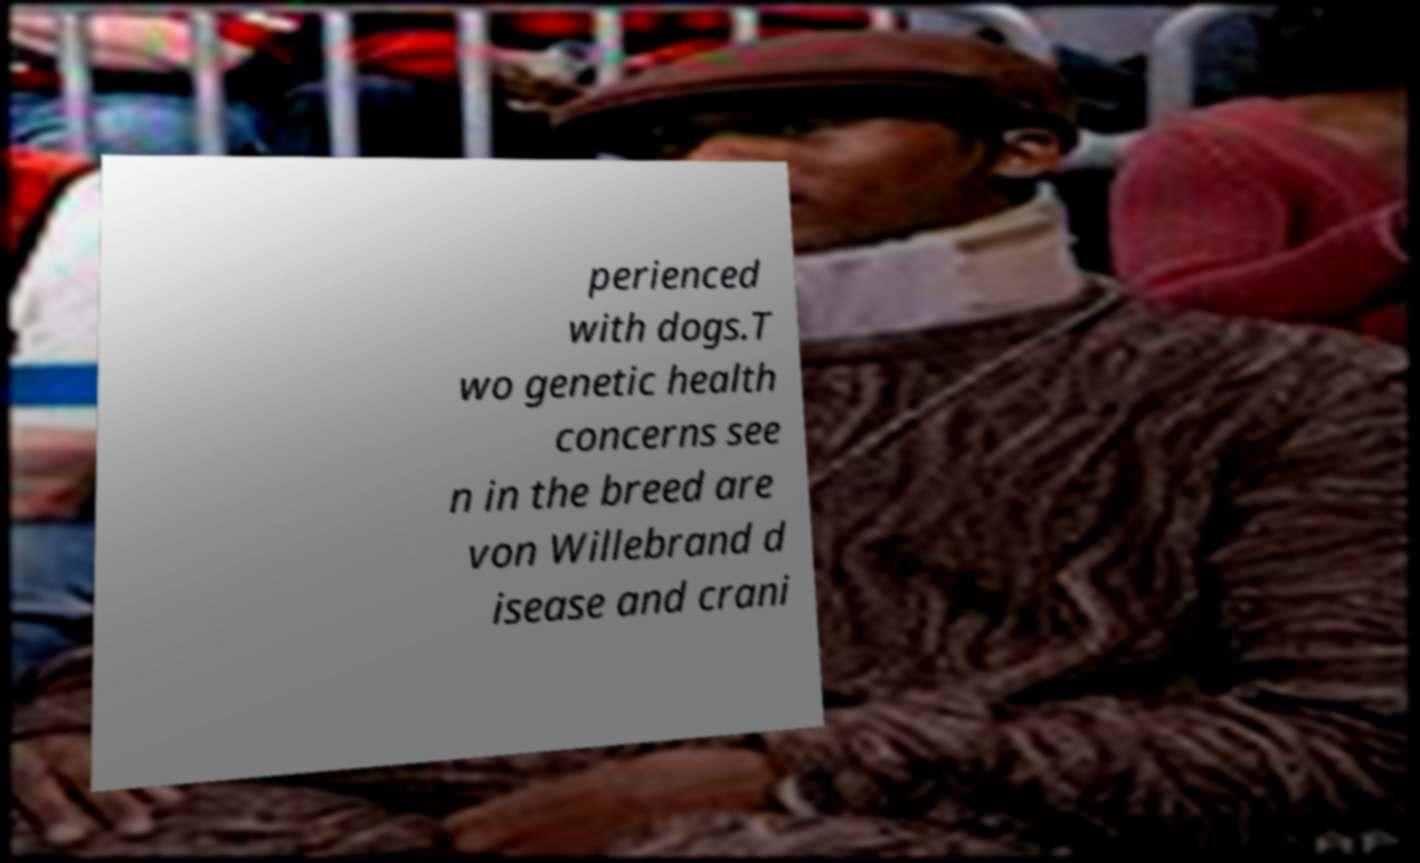For documentation purposes, I need the text within this image transcribed. Could you provide that? perienced with dogs.T wo genetic health concerns see n in the breed are von Willebrand d isease and crani 